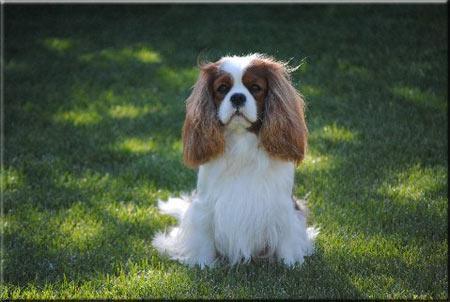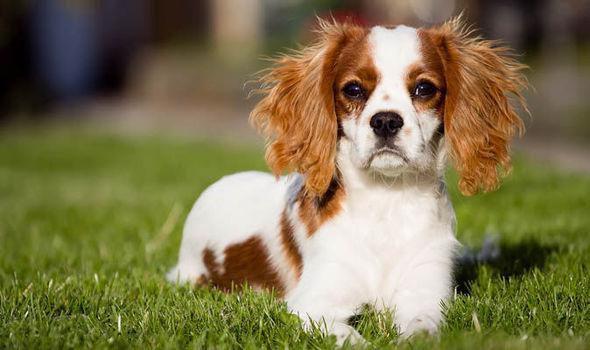The first image is the image on the left, the second image is the image on the right. Assess this claim about the two images: "The spaniel in the left image is in a forward sitting position outdoors.". Correct or not? Answer yes or no. Yes. The first image is the image on the left, the second image is the image on the right. Considering the images on both sides, is "You can clearly see at least one dogs leg, unobstructed by hanging fur." valid? Answer yes or no. No. 